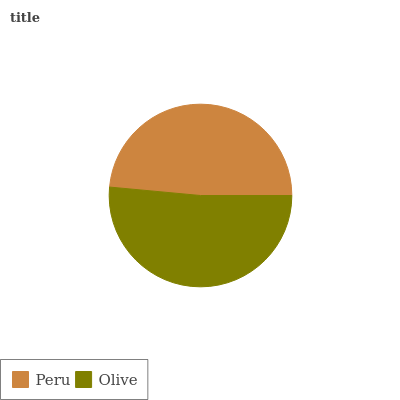Is Peru the minimum?
Answer yes or no. Yes. Is Olive the maximum?
Answer yes or no. Yes. Is Olive the minimum?
Answer yes or no. No. Is Olive greater than Peru?
Answer yes or no. Yes. Is Peru less than Olive?
Answer yes or no. Yes. Is Peru greater than Olive?
Answer yes or no. No. Is Olive less than Peru?
Answer yes or no. No. Is Olive the high median?
Answer yes or no. Yes. Is Peru the low median?
Answer yes or no. Yes. Is Peru the high median?
Answer yes or no. No. Is Olive the low median?
Answer yes or no. No. 